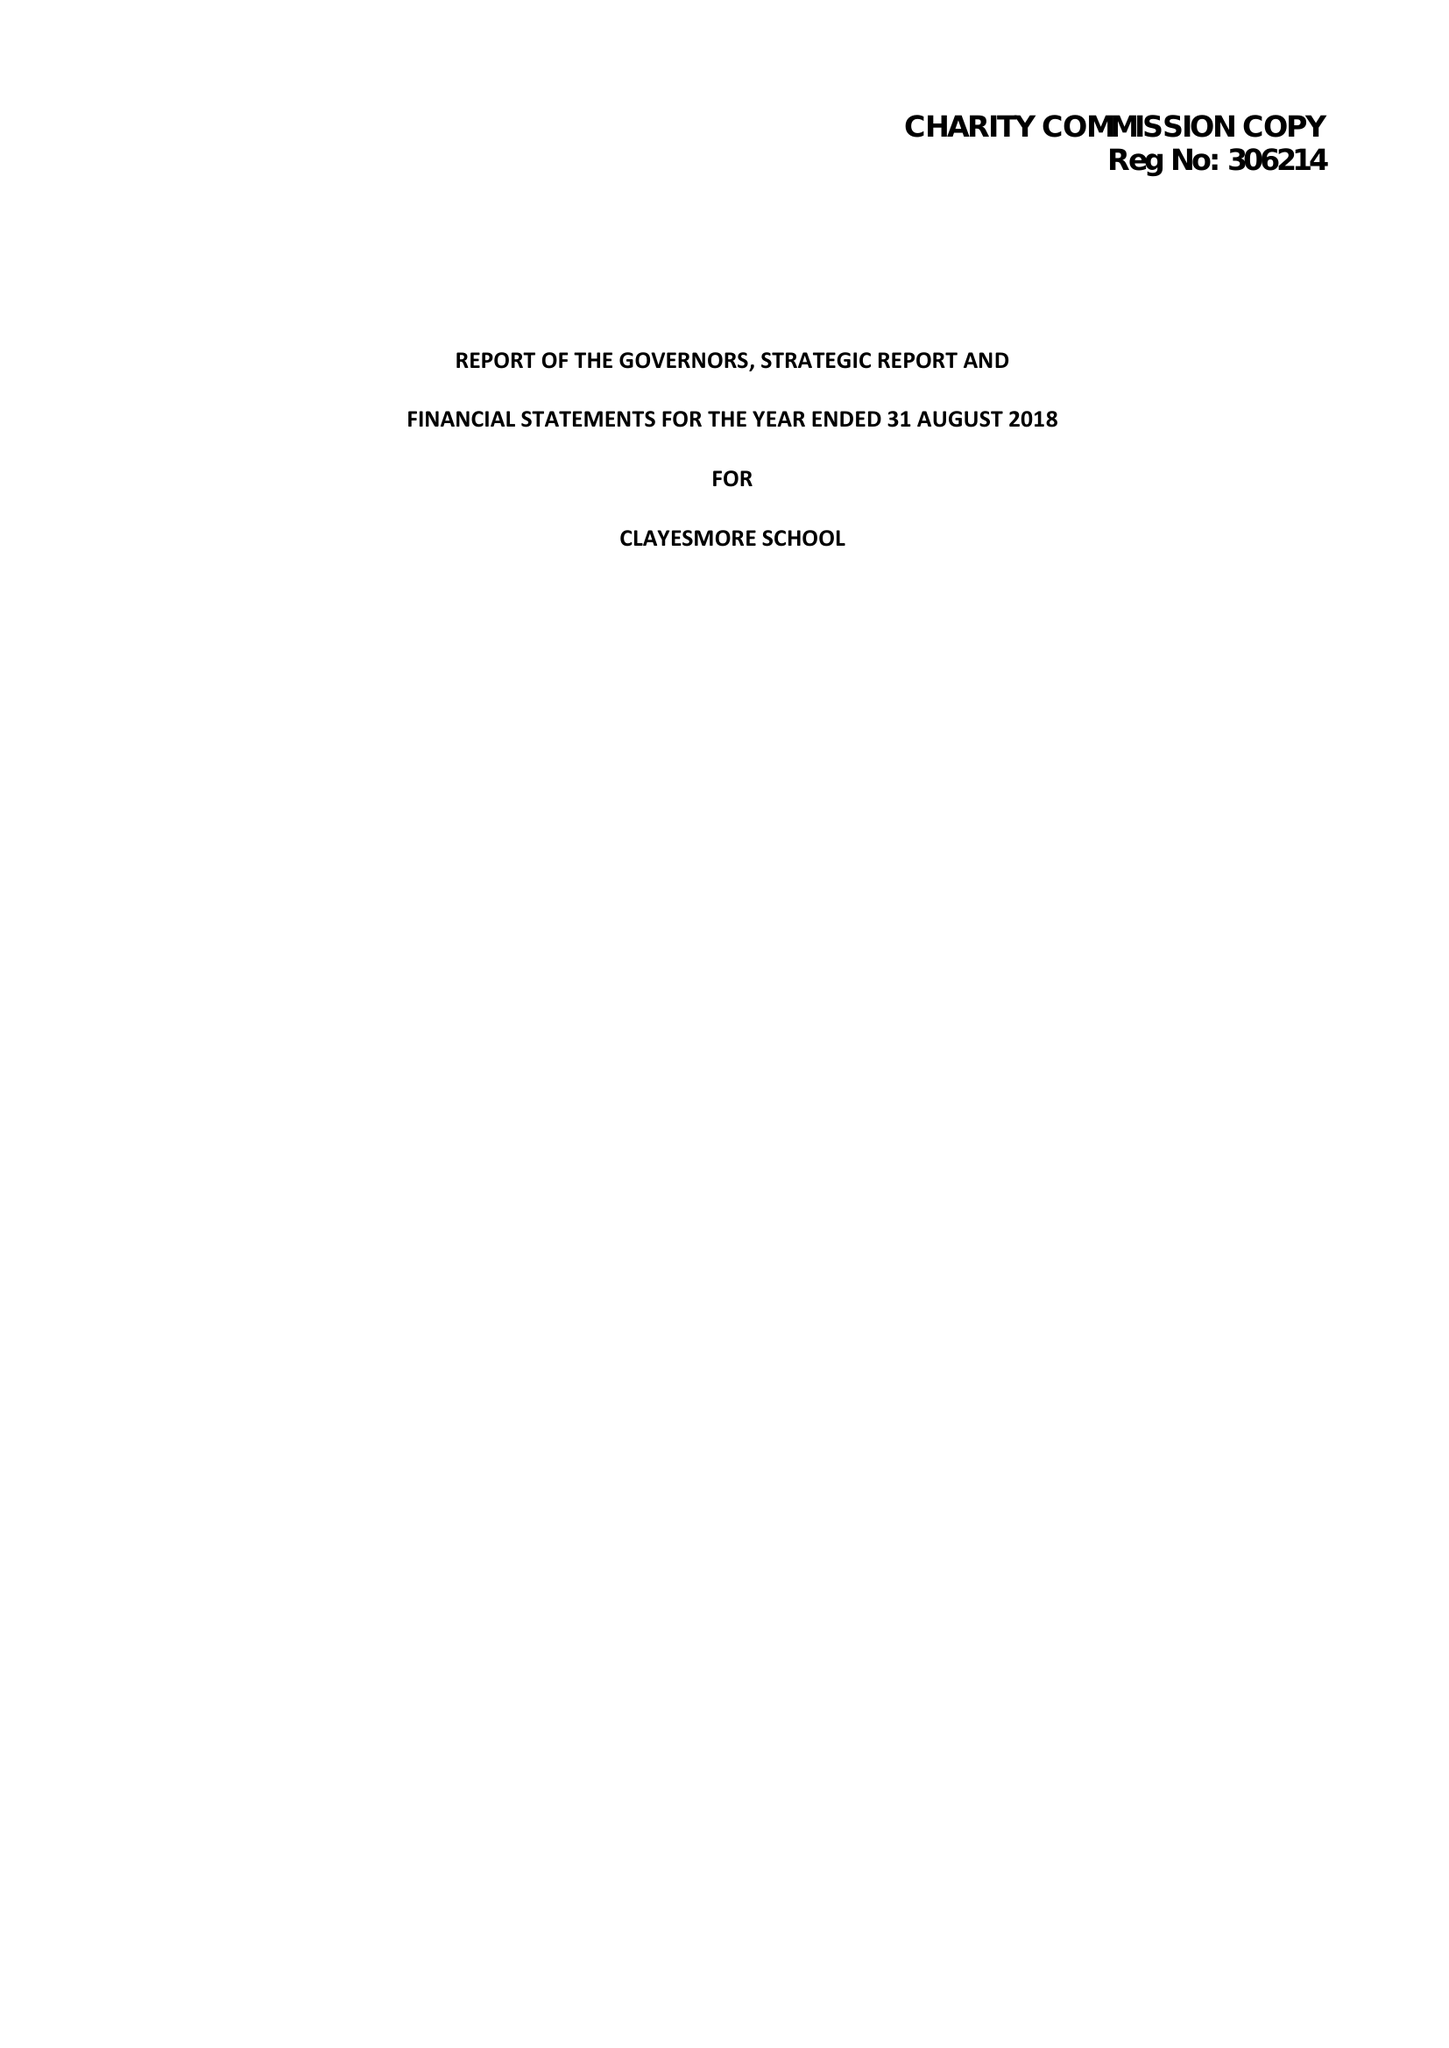What is the value for the address__postcode?
Answer the question using a single word or phrase. DT11 8LL 